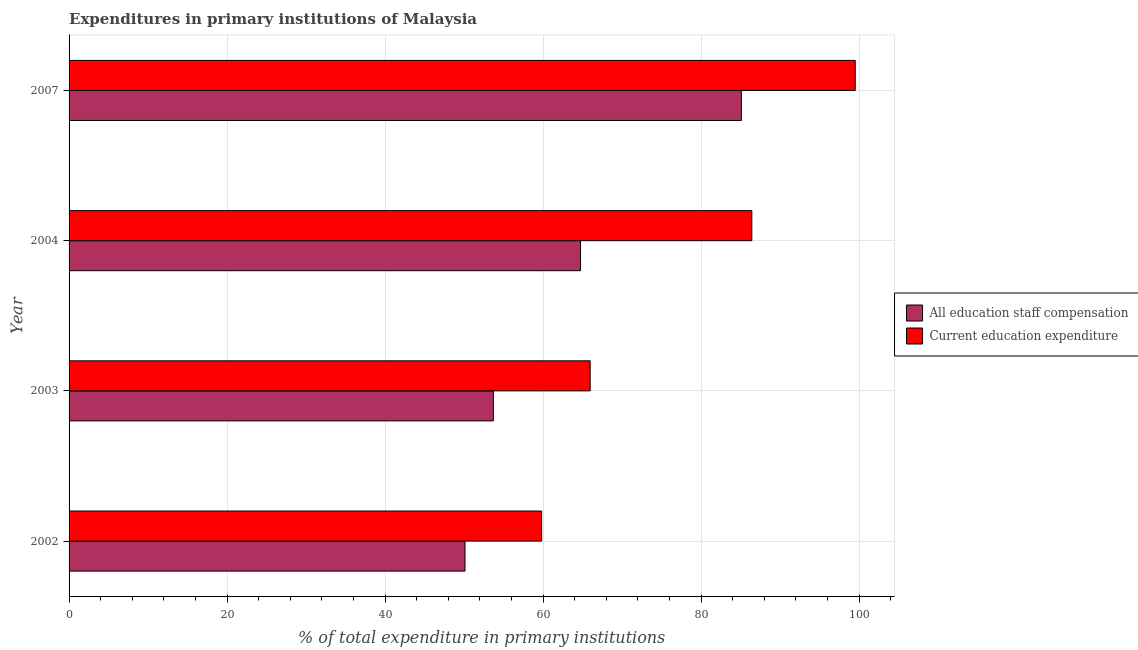How many groups of bars are there?
Make the answer very short. 4. Are the number of bars per tick equal to the number of legend labels?
Offer a terse response. Yes. Are the number of bars on each tick of the Y-axis equal?
Provide a succinct answer. Yes. What is the expenditure in staff compensation in 2007?
Your answer should be compact. 85.1. Across all years, what is the maximum expenditure in staff compensation?
Keep it short and to the point. 85.1. Across all years, what is the minimum expenditure in education?
Ensure brevity in your answer.  59.82. What is the total expenditure in education in the graph?
Provide a succinct answer. 311.72. What is the difference between the expenditure in education in 2002 and that in 2003?
Keep it short and to the point. -6.14. What is the difference between the expenditure in staff compensation in 2004 and the expenditure in education in 2002?
Provide a succinct answer. 4.92. What is the average expenditure in staff compensation per year?
Your response must be concise. 63.42. In the year 2002, what is the difference between the expenditure in staff compensation and expenditure in education?
Provide a short and direct response. -9.7. What is the ratio of the expenditure in education in 2002 to that in 2003?
Offer a terse response. 0.91. Is the expenditure in education in 2002 less than that in 2004?
Make the answer very short. Yes. Is the difference between the expenditure in staff compensation in 2002 and 2007 greater than the difference between the expenditure in education in 2002 and 2007?
Your answer should be compact. Yes. What is the difference between the highest and the second highest expenditure in staff compensation?
Keep it short and to the point. 20.36. What is the difference between the highest and the lowest expenditure in education?
Make the answer very short. 39.69. In how many years, is the expenditure in staff compensation greater than the average expenditure in staff compensation taken over all years?
Your answer should be very brief. 2. Is the sum of the expenditure in staff compensation in 2003 and 2004 greater than the maximum expenditure in education across all years?
Your answer should be compact. Yes. What does the 1st bar from the top in 2004 represents?
Provide a succinct answer. Current education expenditure. What does the 1st bar from the bottom in 2002 represents?
Provide a short and direct response. All education staff compensation. How many bars are there?
Your response must be concise. 8. Are all the bars in the graph horizontal?
Your response must be concise. Yes. Are the values on the major ticks of X-axis written in scientific E-notation?
Give a very brief answer. No. Does the graph contain any zero values?
Give a very brief answer. No. Where does the legend appear in the graph?
Provide a short and direct response. Center right. What is the title of the graph?
Ensure brevity in your answer.  Expenditures in primary institutions of Malaysia. What is the label or title of the X-axis?
Your answer should be compact. % of total expenditure in primary institutions. What is the % of total expenditure in primary institutions in All education staff compensation in 2002?
Your answer should be very brief. 50.12. What is the % of total expenditure in primary institutions in Current education expenditure in 2002?
Provide a succinct answer. 59.82. What is the % of total expenditure in primary institutions in All education staff compensation in 2003?
Your response must be concise. 53.71. What is the % of total expenditure in primary institutions in Current education expenditure in 2003?
Give a very brief answer. 65.96. What is the % of total expenditure in primary institutions of All education staff compensation in 2004?
Provide a short and direct response. 64.74. What is the % of total expenditure in primary institutions in Current education expenditure in 2004?
Ensure brevity in your answer.  86.43. What is the % of total expenditure in primary institutions of All education staff compensation in 2007?
Your answer should be compact. 85.1. What is the % of total expenditure in primary institutions of Current education expenditure in 2007?
Your answer should be very brief. 99.51. Across all years, what is the maximum % of total expenditure in primary institutions of All education staff compensation?
Keep it short and to the point. 85.1. Across all years, what is the maximum % of total expenditure in primary institutions in Current education expenditure?
Offer a very short reply. 99.51. Across all years, what is the minimum % of total expenditure in primary institutions in All education staff compensation?
Provide a short and direct response. 50.12. Across all years, what is the minimum % of total expenditure in primary institutions of Current education expenditure?
Offer a terse response. 59.82. What is the total % of total expenditure in primary institutions in All education staff compensation in the graph?
Your answer should be compact. 253.67. What is the total % of total expenditure in primary institutions in Current education expenditure in the graph?
Ensure brevity in your answer.  311.72. What is the difference between the % of total expenditure in primary institutions in All education staff compensation in 2002 and that in 2003?
Give a very brief answer. -3.59. What is the difference between the % of total expenditure in primary institutions in Current education expenditure in 2002 and that in 2003?
Offer a terse response. -6.14. What is the difference between the % of total expenditure in primary institutions in All education staff compensation in 2002 and that in 2004?
Provide a short and direct response. -14.62. What is the difference between the % of total expenditure in primary institutions of Current education expenditure in 2002 and that in 2004?
Ensure brevity in your answer.  -26.61. What is the difference between the % of total expenditure in primary institutions in All education staff compensation in 2002 and that in 2007?
Your answer should be compact. -34.98. What is the difference between the % of total expenditure in primary institutions of Current education expenditure in 2002 and that in 2007?
Make the answer very short. -39.69. What is the difference between the % of total expenditure in primary institutions in All education staff compensation in 2003 and that in 2004?
Offer a terse response. -11.04. What is the difference between the % of total expenditure in primary institutions in Current education expenditure in 2003 and that in 2004?
Offer a terse response. -20.46. What is the difference between the % of total expenditure in primary institutions of All education staff compensation in 2003 and that in 2007?
Offer a terse response. -31.4. What is the difference between the % of total expenditure in primary institutions of Current education expenditure in 2003 and that in 2007?
Offer a terse response. -33.55. What is the difference between the % of total expenditure in primary institutions in All education staff compensation in 2004 and that in 2007?
Ensure brevity in your answer.  -20.36. What is the difference between the % of total expenditure in primary institutions of Current education expenditure in 2004 and that in 2007?
Provide a short and direct response. -13.09. What is the difference between the % of total expenditure in primary institutions in All education staff compensation in 2002 and the % of total expenditure in primary institutions in Current education expenditure in 2003?
Your answer should be very brief. -15.84. What is the difference between the % of total expenditure in primary institutions in All education staff compensation in 2002 and the % of total expenditure in primary institutions in Current education expenditure in 2004?
Ensure brevity in your answer.  -36.31. What is the difference between the % of total expenditure in primary institutions in All education staff compensation in 2002 and the % of total expenditure in primary institutions in Current education expenditure in 2007?
Make the answer very short. -49.39. What is the difference between the % of total expenditure in primary institutions in All education staff compensation in 2003 and the % of total expenditure in primary institutions in Current education expenditure in 2004?
Keep it short and to the point. -32.72. What is the difference between the % of total expenditure in primary institutions in All education staff compensation in 2003 and the % of total expenditure in primary institutions in Current education expenditure in 2007?
Provide a short and direct response. -45.81. What is the difference between the % of total expenditure in primary institutions of All education staff compensation in 2004 and the % of total expenditure in primary institutions of Current education expenditure in 2007?
Give a very brief answer. -34.77. What is the average % of total expenditure in primary institutions of All education staff compensation per year?
Ensure brevity in your answer.  63.42. What is the average % of total expenditure in primary institutions of Current education expenditure per year?
Make the answer very short. 77.93. In the year 2002, what is the difference between the % of total expenditure in primary institutions of All education staff compensation and % of total expenditure in primary institutions of Current education expenditure?
Make the answer very short. -9.7. In the year 2003, what is the difference between the % of total expenditure in primary institutions of All education staff compensation and % of total expenditure in primary institutions of Current education expenditure?
Ensure brevity in your answer.  -12.26. In the year 2004, what is the difference between the % of total expenditure in primary institutions in All education staff compensation and % of total expenditure in primary institutions in Current education expenditure?
Provide a short and direct response. -21.68. In the year 2007, what is the difference between the % of total expenditure in primary institutions of All education staff compensation and % of total expenditure in primary institutions of Current education expenditure?
Offer a terse response. -14.41. What is the ratio of the % of total expenditure in primary institutions in All education staff compensation in 2002 to that in 2003?
Make the answer very short. 0.93. What is the ratio of the % of total expenditure in primary institutions of Current education expenditure in 2002 to that in 2003?
Make the answer very short. 0.91. What is the ratio of the % of total expenditure in primary institutions of All education staff compensation in 2002 to that in 2004?
Your answer should be compact. 0.77. What is the ratio of the % of total expenditure in primary institutions in Current education expenditure in 2002 to that in 2004?
Provide a succinct answer. 0.69. What is the ratio of the % of total expenditure in primary institutions of All education staff compensation in 2002 to that in 2007?
Give a very brief answer. 0.59. What is the ratio of the % of total expenditure in primary institutions in Current education expenditure in 2002 to that in 2007?
Keep it short and to the point. 0.6. What is the ratio of the % of total expenditure in primary institutions of All education staff compensation in 2003 to that in 2004?
Provide a short and direct response. 0.83. What is the ratio of the % of total expenditure in primary institutions in Current education expenditure in 2003 to that in 2004?
Your answer should be very brief. 0.76. What is the ratio of the % of total expenditure in primary institutions in All education staff compensation in 2003 to that in 2007?
Give a very brief answer. 0.63. What is the ratio of the % of total expenditure in primary institutions of Current education expenditure in 2003 to that in 2007?
Your response must be concise. 0.66. What is the ratio of the % of total expenditure in primary institutions of All education staff compensation in 2004 to that in 2007?
Your response must be concise. 0.76. What is the ratio of the % of total expenditure in primary institutions in Current education expenditure in 2004 to that in 2007?
Your answer should be compact. 0.87. What is the difference between the highest and the second highest % of total expenditure in primary institutions in All education staff compensation?
Your answer should be compact. 20.36. What is the difference between the highest and the second highest % of total expenditure in primary institutions in Current education expenditure?
Give a very brief answer. 13.09. What is the difference between the highest and the lowest % of total expenditure in primary institutions in All education staff compensation?
Provide a succinct answer. 34.98. What is the difference between the highest and the lowest % of total expenditure in primary institutions in Current education expenditure?
Make the answer very short. 39.69. 